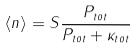<formula> <loc_0><loc_0><loc_500><loc_500>\langle n \rangle = S \frac { P _ { t o t } } { P _ { t o t } + \kappa _ { t o t } }</formula> 